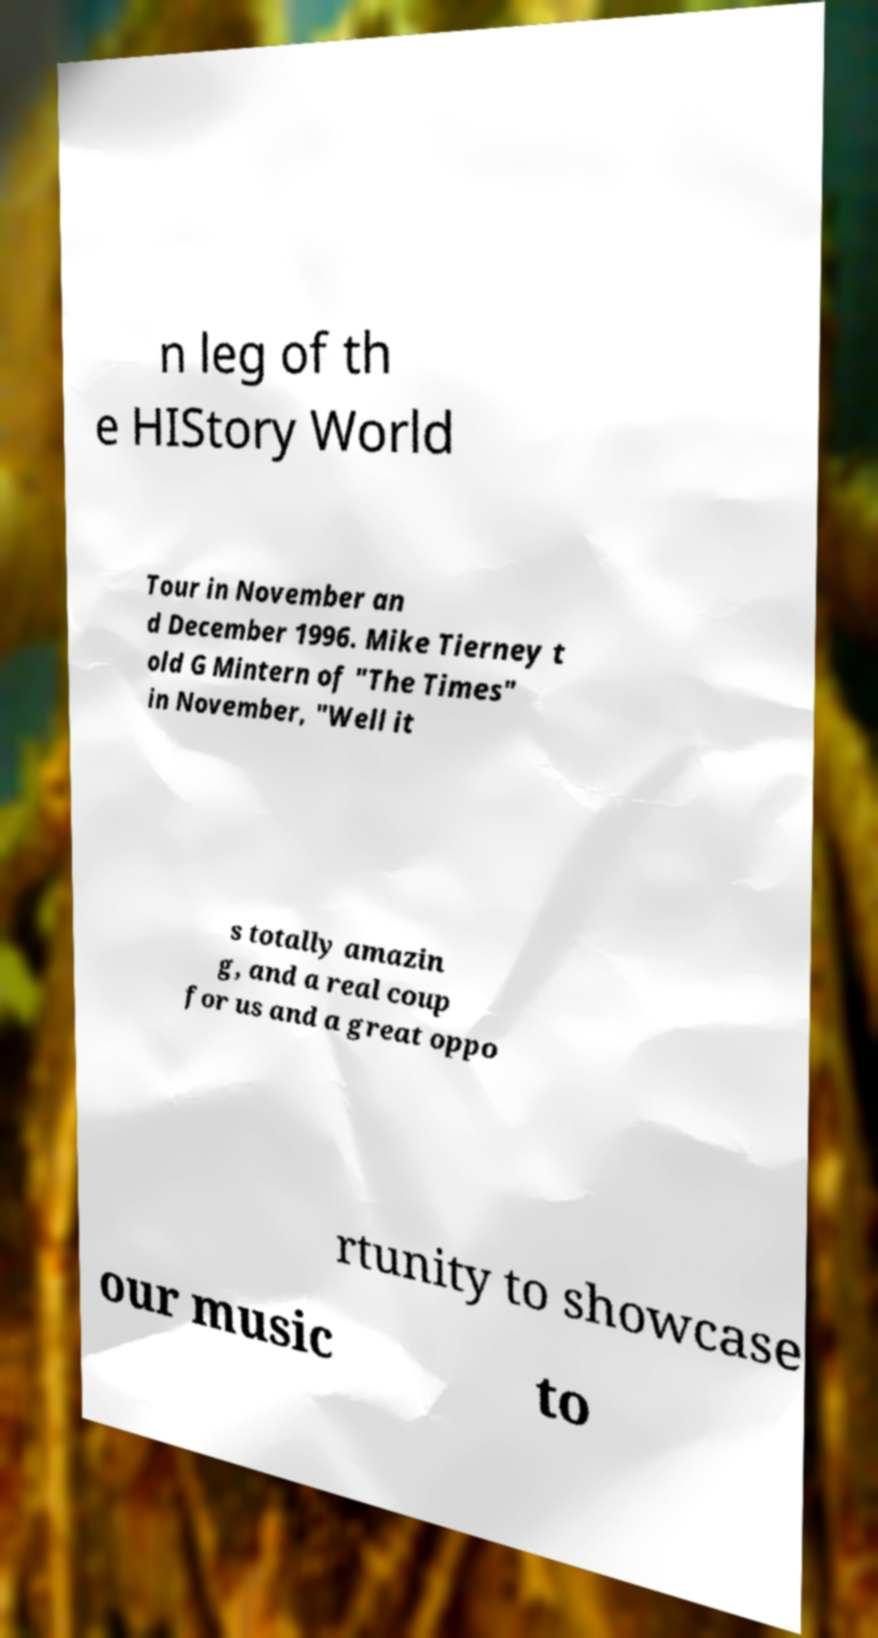Please identify and transcribe the text found in this image. n leg of th e HIStory World Tour in November an d December 1996. Mike Tierney t old G Mintern of "The Times" in November, "Well it s totally amazin g, and a real coup for us and a great oppo rtunity to showcase our music to 